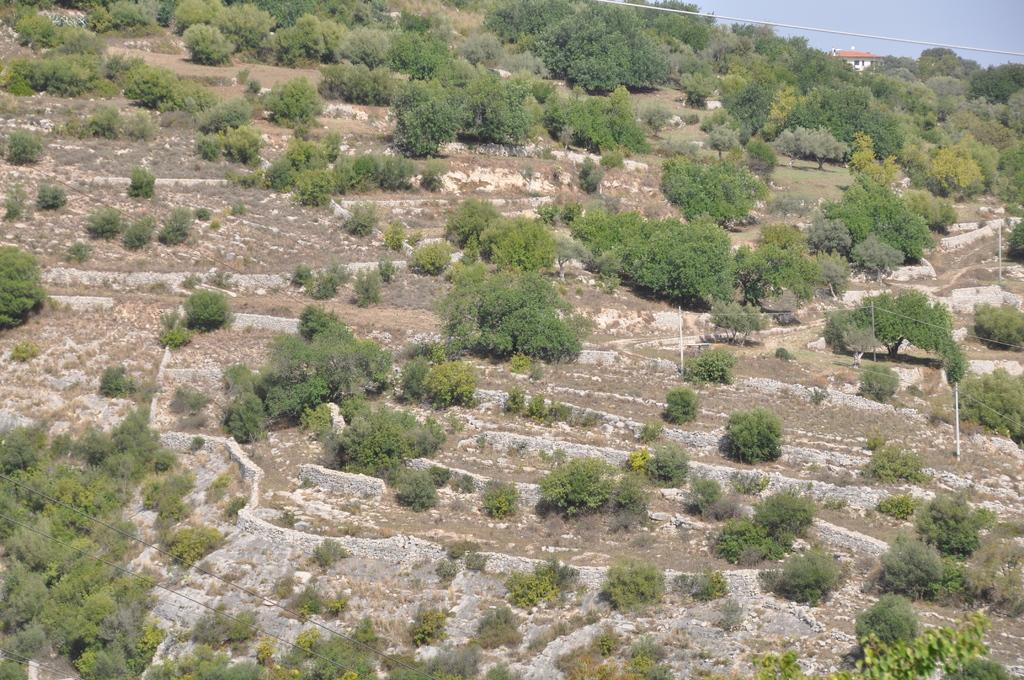What type of vegetation is present on the ground in the image? There are trees on the ground in the image. What structure can be seen behind the trees? There is a building visible behind the trees. What is the condition of the sky in the image? The sky is clear in the image. What type of development is taking place in the image? There is no indication of any development taking place in the image; it primarily features trees, a building, and the sky. Can you see a board in the image? There is no board present in the image. 